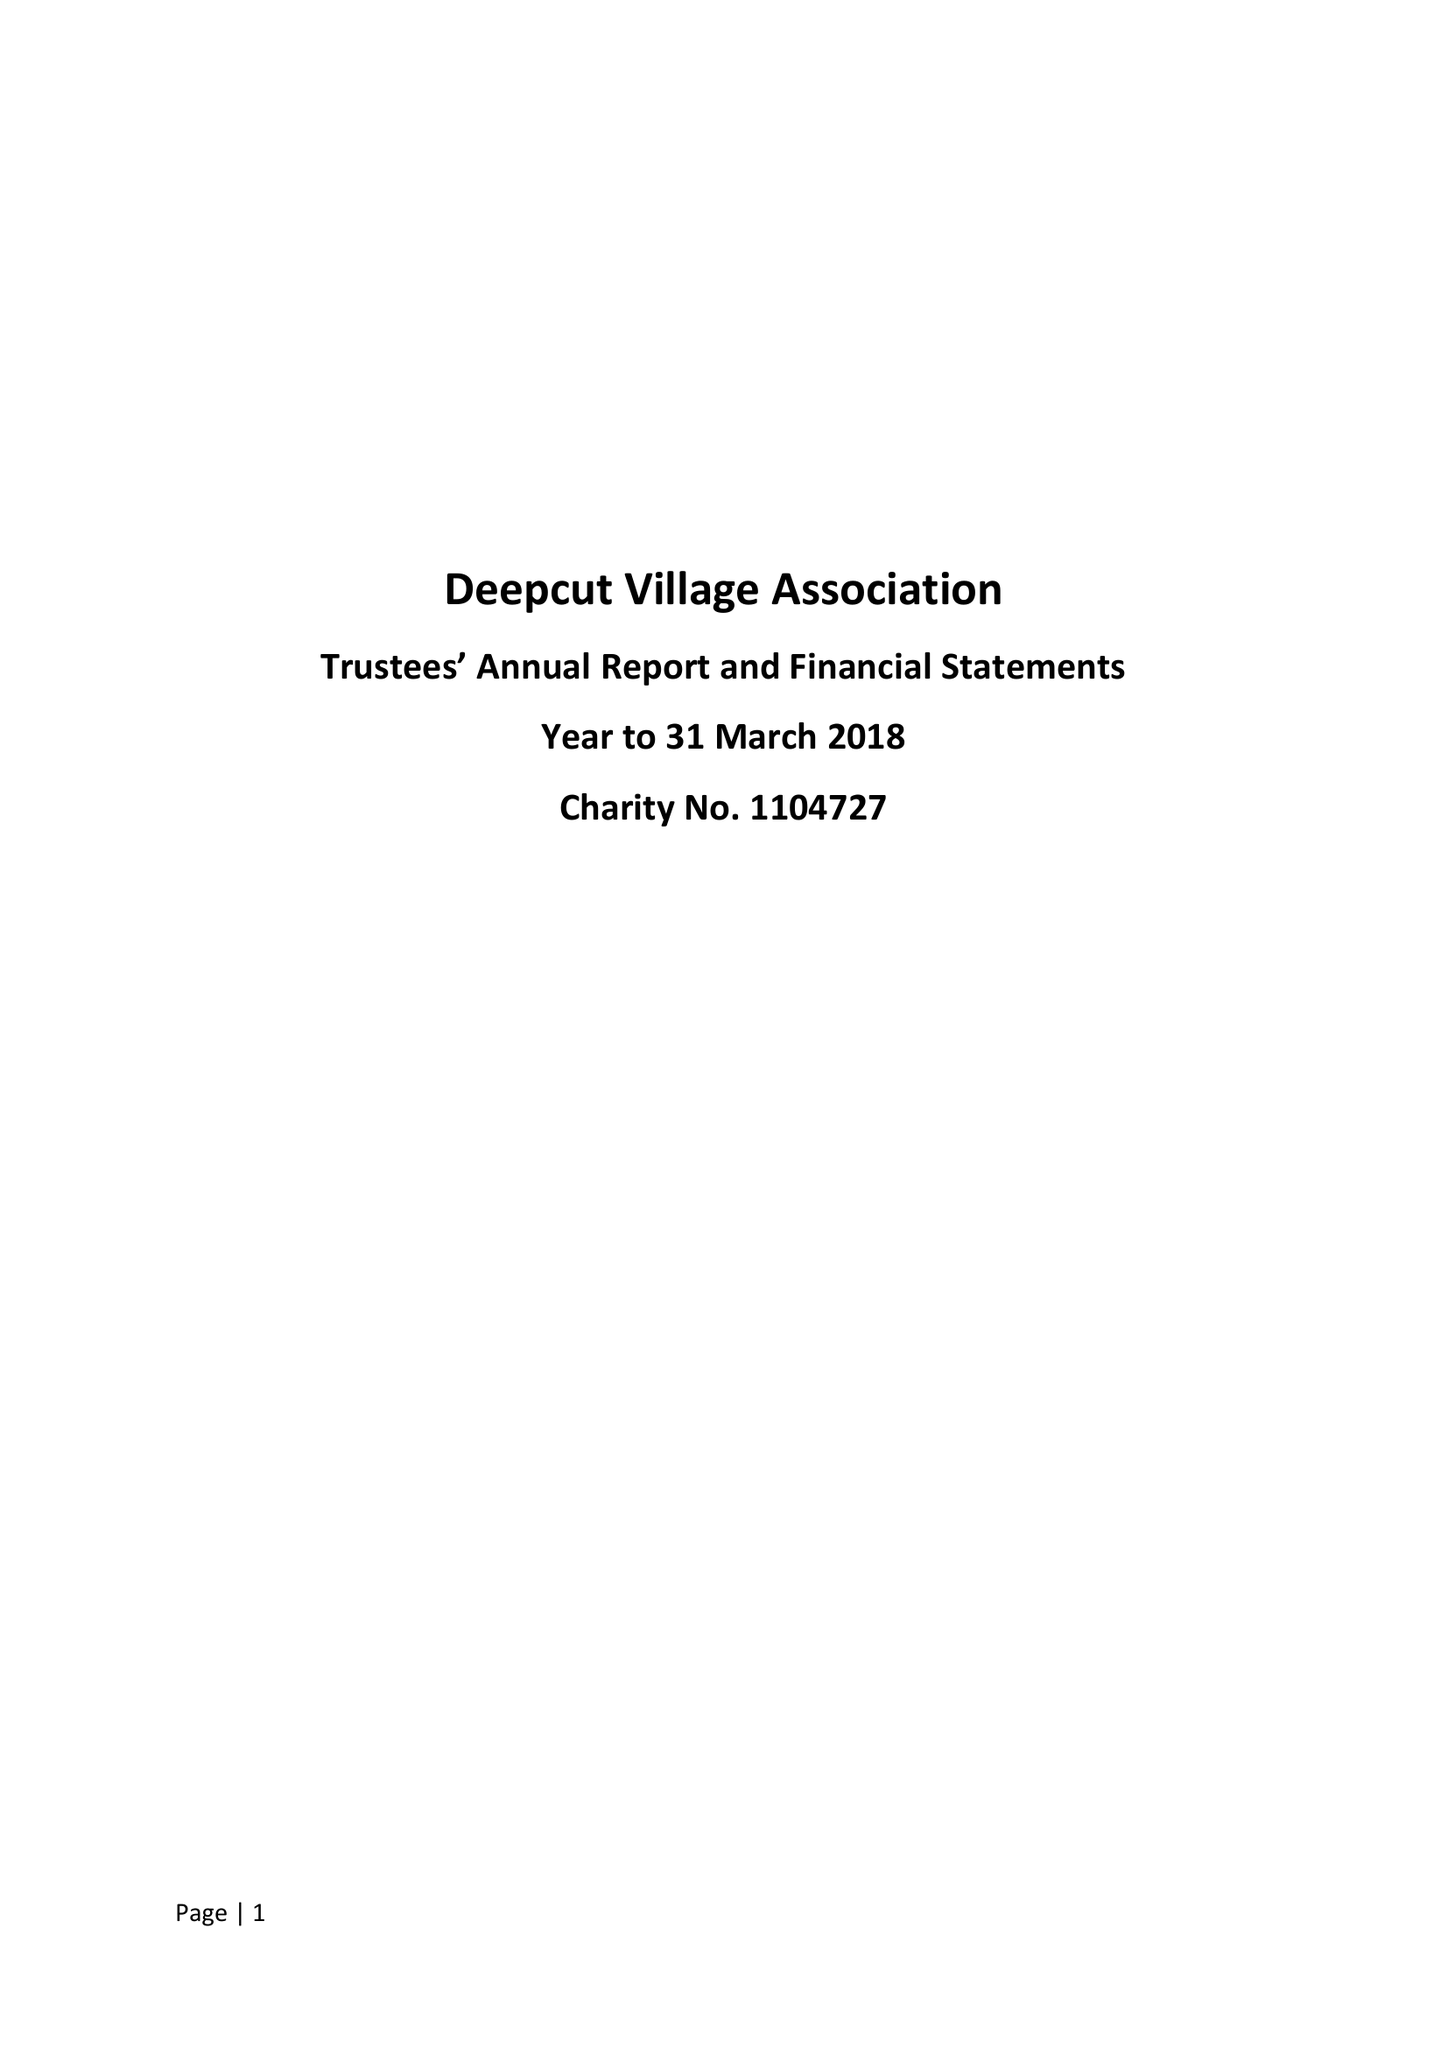What is the value for the address__post_town?
Answer the question using a single word or phrase. CAMBERLEY 